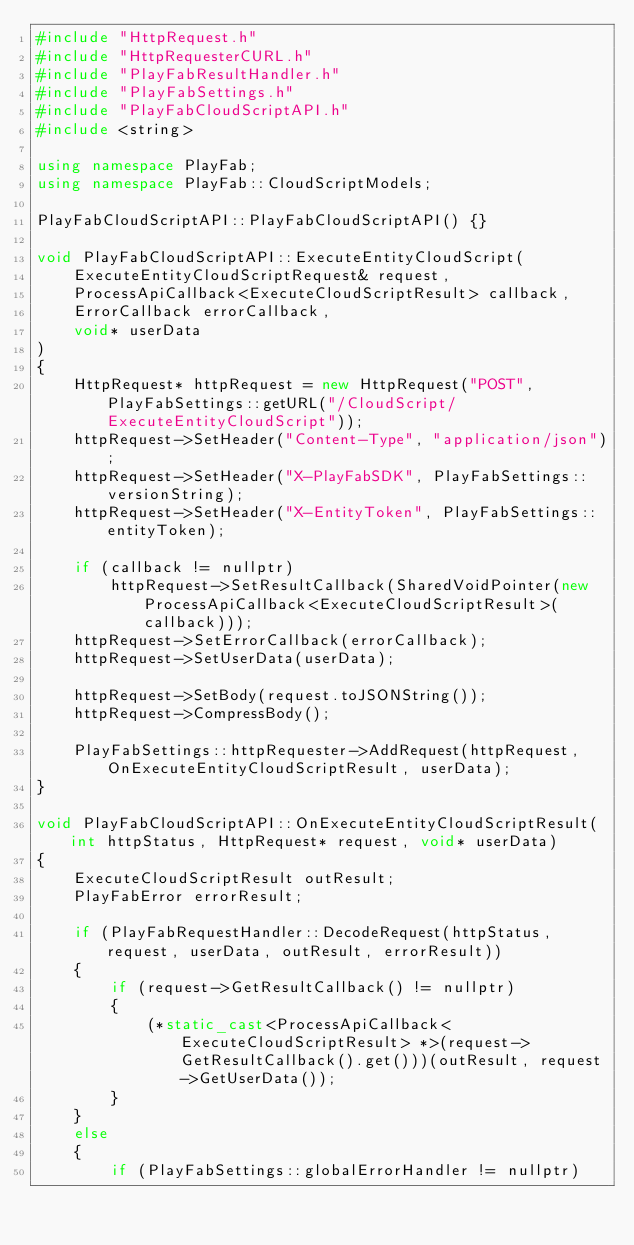<code> <loc_0><loc_0><loc_500><loc_500><_C++_>#include "HttpRequest.h"
#include "HttpRequesterCURL.h"
#include "PlayFabResultHandler.h"
#include "PlayFabSettings.h"
#include "PlayFabCloudScriptAPI.h"
#include <string>

using namespace PlayFab;
using namespace PlayFab::CloudScriptModels;

PlayFabCloudScriptAPI::PlayFabCloudScriptAPI() {}

void PlayFabCloudScriptAPI::ExecuteEntityCloudScript(
    ExecuteEntityCloudScriptRequest& request,
    ProcessApiCallback<ExecuteCloudScriptResult> callback,
    ErrorCallback errorCallback,
    void* userData
)
{
    HttpRequest* httpRequest = new HttpRequest("POST", PlayFabSettings::getURL("/CloudScript/ExecuteEntityCloudScript"));
    httpRequest->SetHeader("Content-Type", "application/json");
    httpRequest->SetHeader("X-PlayFabSDK", PlayFabSettings::versionString);
    httpRequest->SetHeader("X-EntityToken", PlayFabSettings::entityToken);

    if (callback != nullptr)
        httpRequest->SetResultCallback(SharedVoidPointer(new ProcessApiCallback<ExecuteCloudScriptResult>(callback)));
    httpRequest->SetErrorCallback(errorCallback);
    httpRequest->SetUserData(userData);

    httpRequest->SetBody(request.toJSONString());
    httpRequest->CompressBody();

    PlayFabSettings::httpRequester->AddRequest(httpRequest, OnExecuteEntityCloudScriptResult, userData);
}

void PlayFabCloudScriptAPI::OnExecuteEntityCloudScriptResult(int httpStatus, HttpRequest* request, void* userData)
{
    ExecuteCloudScriptResult outResult;
    PlayFabError errorResult;

    if (PlayFabRequestHandler::DecodeRequest(httpStatus, request, userData, outResult, errorResult))
    {
        if (request->GetResultCallback() != nullptr)
        {
            (*static_cast<ProcessApiCallback<ExecuteCloudScriptResult> *>(request->GetResultCallback().get()))(outResult, request->GetUserData());
        }
    }
    else
    {
        if (PlayFabSettings::globalErrorHandler != nullptr)</code> 